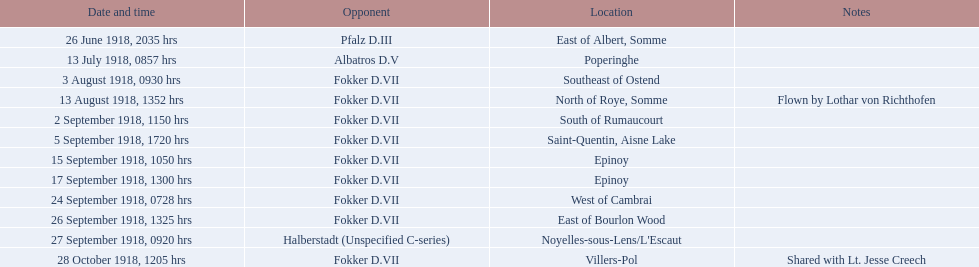Who was kindley's most frequently defeated adversary? Fokker D.VII. 